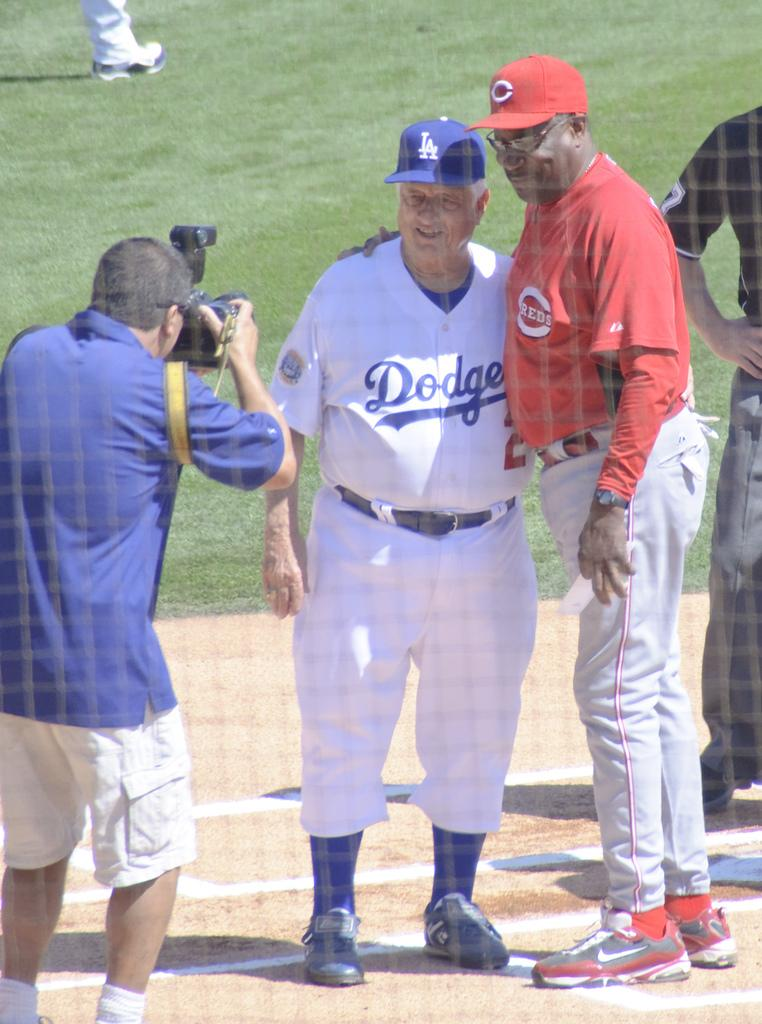<image>
Offer a succinct explanation of the picture presented. A photographer is taking a picture of two older men, a white man dressed in a Dodgers uniform and a black man in a Reds uniform. 